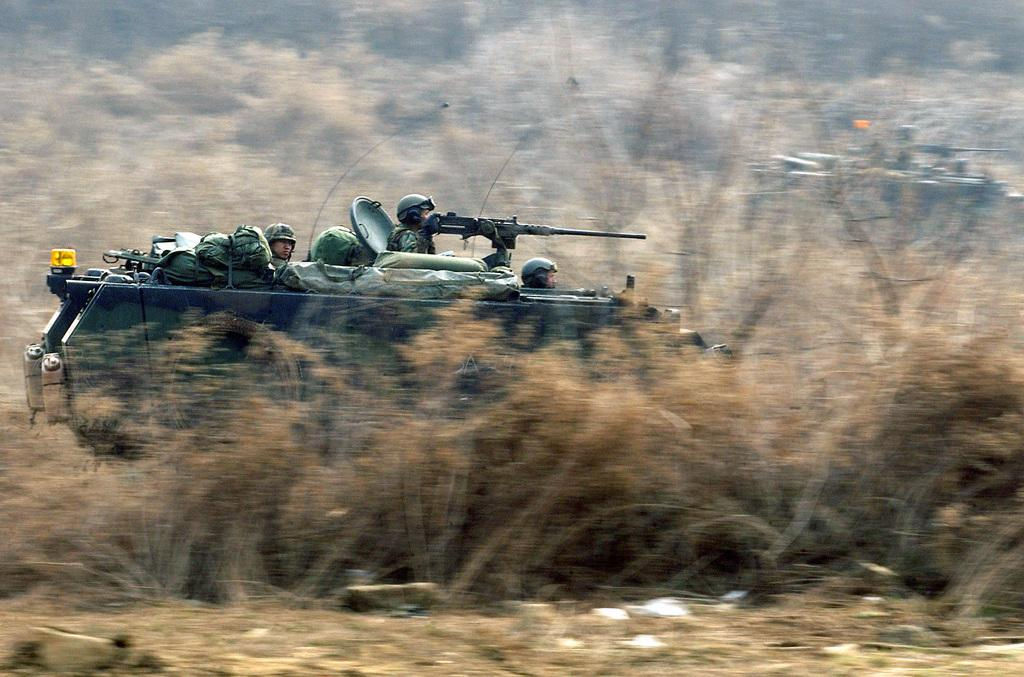What is located in the foreground of the picture? In the foreground of the picture, there are plants, soil, soldiers, and an army tank. What type of vegetation can be seen in the foreground? Plants can be seen in the foreground of the picture. What else is present in the foreground besides the plants? There are soldiers and an army tank in the foreground of the picture. What can be seen in the background of the picture? In the background of the picture, there are plants and an army tank. What type of fan is visible in the picture? There is no fan present in the picture. Can you describe the secretary's desk in the image? There is no secretary or desk present in the image. 